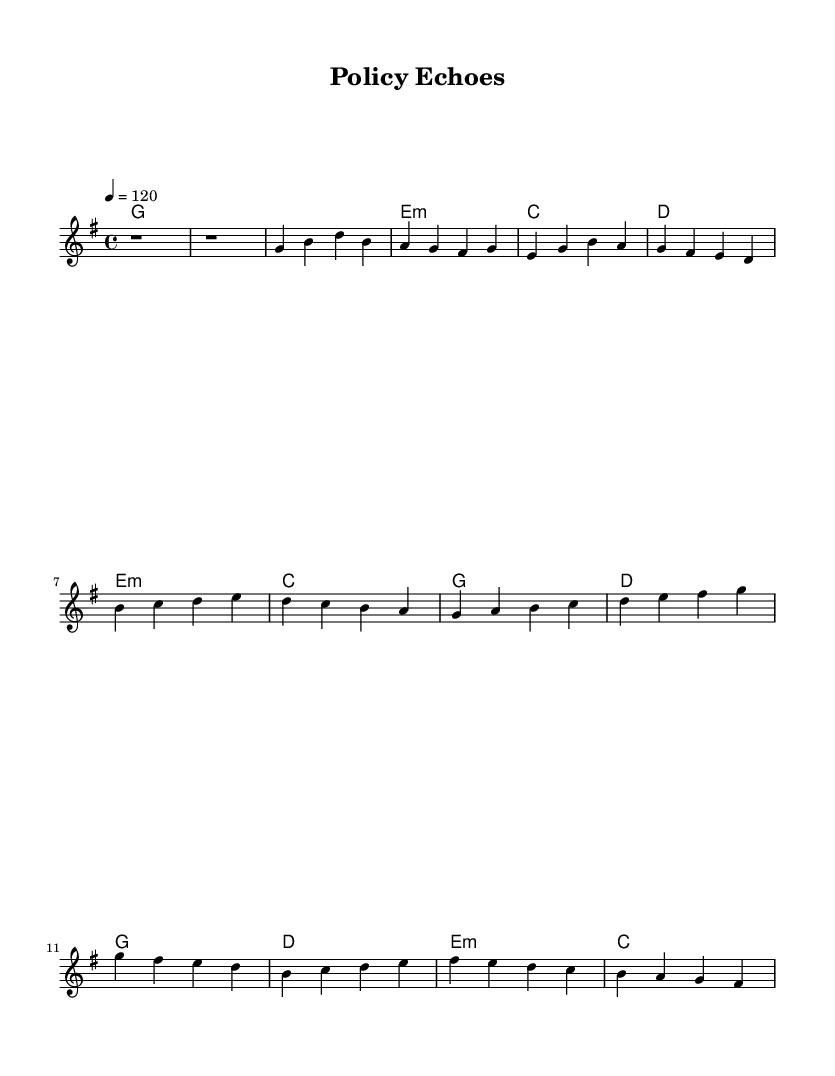What is the key signature of this music? The key signature is G major, indicated by one sharp (F#) at the beginning of the staff.
Answer: G major What is the time signature of this piece? The time signature is 4/4, which is indicated at the beginning of the sheet music, meaning there are four beats in each measure.
Answer: 4/4 What is the tempo marking for this composition? The tempo marking is 120 beats per minute, noted with the term “4 = 120” after the tempo indication.
Answer: 120 How many measures are in the verse section? The verse section consists of 4 measures, which can be counted from the melody segment designated as the verse.
Answer: 4 What is the structure of the song according to the sheet music? The structure consists of an introduction, verse, pre-chorus, and chorus, as denoted in the layout of the music.
Answer: Intro, Verse, Pre-Chorus, Chorus Which chord is played in the first measure? The first measure contains the G major chord, indicated by the chord symbol placed above the staff.
Answer: G What is the predominant emotion conveyed in the pre-chorus through the choice of chords? The pre-chorus uses emotionally resonant chords (E minor followed by C and G) that typically express reflective feelings, linking to socially conscious themes in K-Pop.
Answer: Reflective 